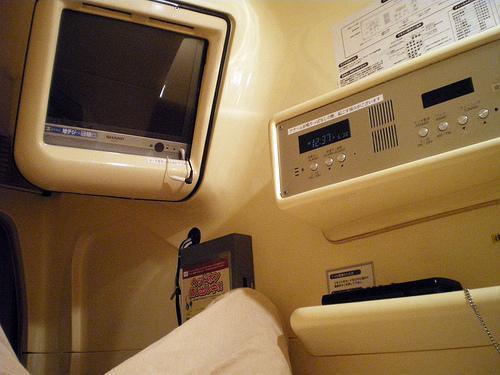How many monitors are there?
Give a very brief answer. 1. 